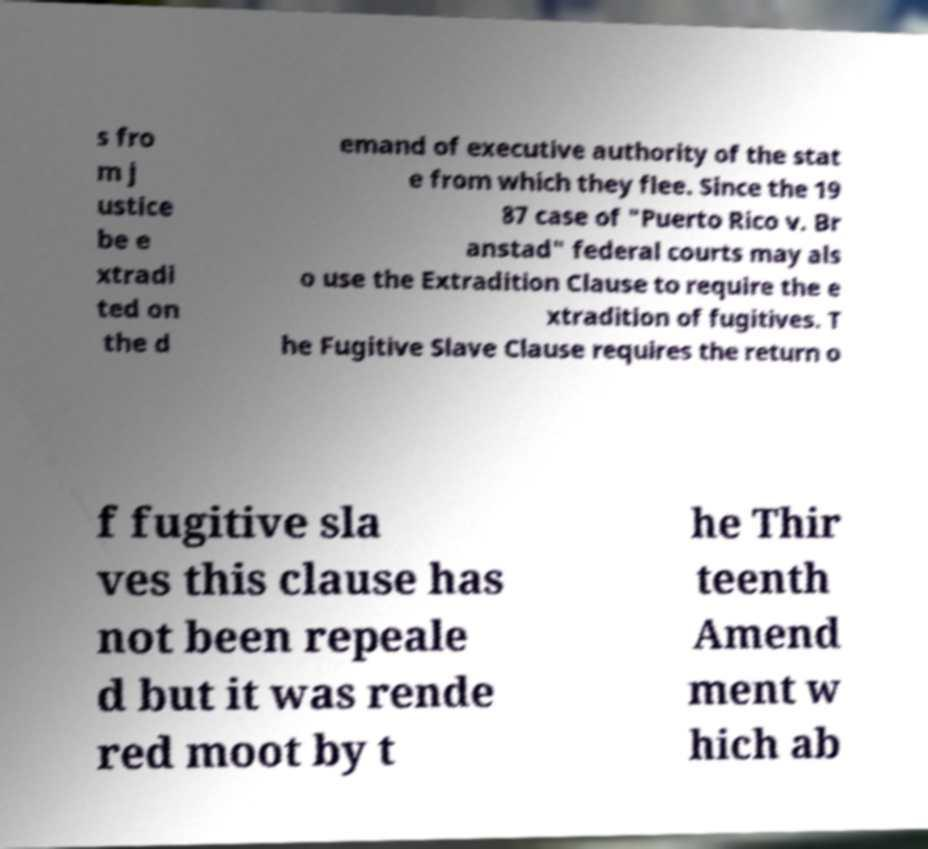Can you read and provide the text displayed in the image?This photo seems to have some interesting text. Can you extract and type it out for me? s fro m j ustice be e xtradi ted on the d emand of executive authority of the stat e from which they flee. Since the 19 87 case of "Puerto Rico v. Br anstad" federal courts may als o use the Extradition Clause to require the e xtradition of fugitives. T he Fugitive Slave Clause requires the return o f fugitive sla ves this clause has not been repeale d but it was rende red moot by t he Thir teenth Amend ment w hich ab 